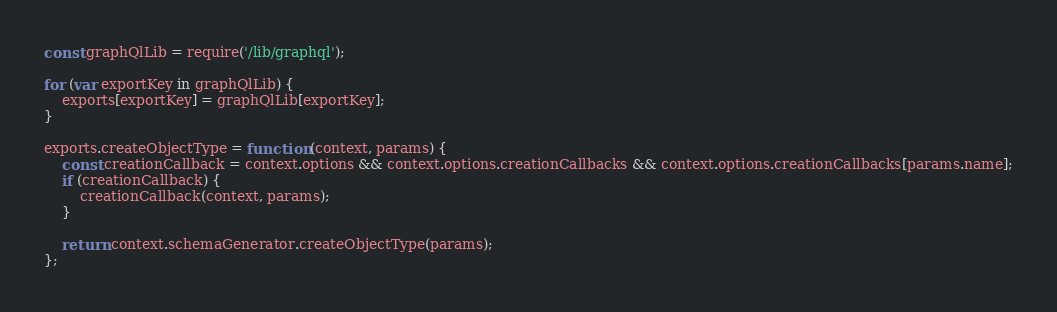Convert code to text. <code><loc_0><loc_0><loc_500><loc_500><_JavaScript_>const graphQlLib = require('/lib/graphql');

for (var exportKey in graphQlLib) {
    exports[exportKey] = graphQlLib[exportKey];
}

exports.createObjectType = function (context, params) {
    const creationCallback = context.options && context.options.creationCallbacks && context.options.creationCallbacks[params.name];
    if (creationCallback) {
        creationCallback(context, params);
    }

    return context.schemaGenerator.createObjectType(params);
};
</code> 